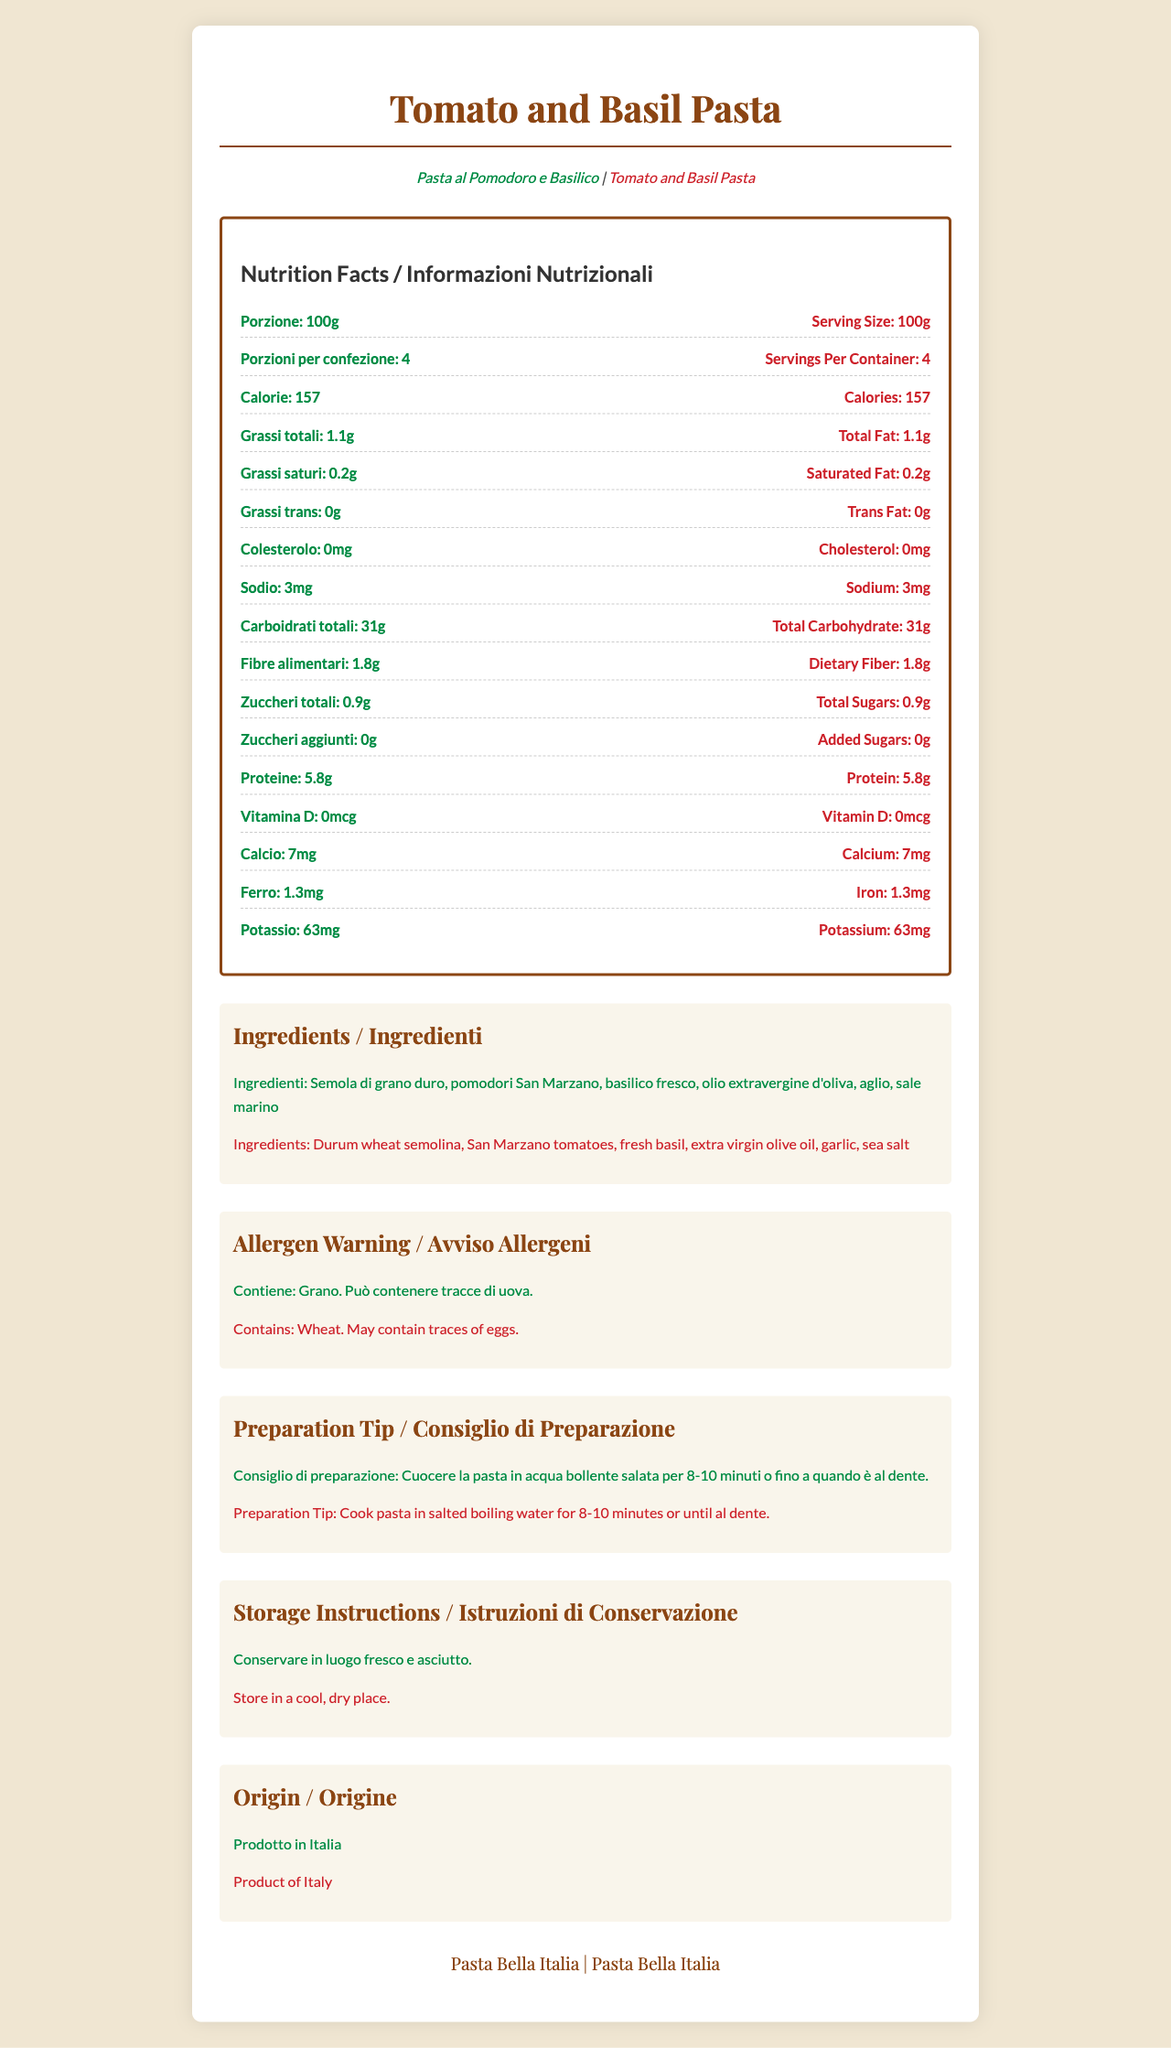What is the serving size in Italian? The serving size in Italian is stated as "Porzione: 100g".
Answer: Porzione: 100g How many servings per container are there? The document states "Servings Per Container: 4".
Answer: 4 How much sodium does a serving contain in English? The English section of the nutrition facts lists sodium as "3mg".
Answer: 3mg What is the amount of dietary fiber in this pasta? The nutritional information shows "Dietary Fiber: 1.8g" in the English section and "Fibre alimentari: 1.8g" in the Italian section.
Answer: 1.8g Which vitamin content is mentioned in the document? The document lists "Vitamin D: 0mcg" in the nutrition facts.
Answer: Vitamin D What are the main ingredients of this pasta dish in Italian? The Italian section lists the ingredients as "Semola di grano duro, pomodori San Marzano, basilico fresco, olio extravergine d'oliva, aglio, sale marino".
Answer: Semola di grano duro, pomodori San Marzano, basilico fresco, olio extravergine d'oliva, aglio, sale marino How much cholesterol does one serving contain? The nutritional information states "Cholesterol: 0mg".
Answer: 0mg What is the name of the product in English? The product name in English is "Tomato and Basil Pasta".
Answer: Tomato and Basil Pasta What is the preparation tip for this pasta? The preparation tip in English is "Cook pasta in salted boiling water for 8-10 minutes or until al dente."
Answer: Cook pasta in salted boiling water for 8-10 minutes or until al dente. What is the brand name of the pasta? The brand name is “Pasta Bella Italia”.
Answer: Pasta Bella Italia Which of the following ingredients is NOT listed in the document? A. Basilico fresco B. Aglio C. Origano D. Olio extravergine d'oliva The ingredients in the document are semola di grano duro (durum wheat semolina), pomodori San Marzano, basilico fresco (fresh basil), olio extravergine d'oliva (extra virgin olive oil), aglio (garlic), and sale marino (sea salt). Origano (oregano) is not listed.
Answer: C. Origano Which of the following nutrients has the highest amount in one serving? 1. Protein 2. Total Carbohydrate 3. Total Sugars 4. Total Fat The nutritional facts state that Total Carbohydrate is 31g, which is higher than Protein (5.8g), Total Sugars (0.9g), and Total Fat (1.1g).
Answer: 2. Total Carbohydrate Does the pasta contain any added sugars? The nutritional information states "Added Sugars: 0g".
Answer: No Summarize the document in a few sentences. The document is a bilingual (Italian and English) nutrition facts label for Tomato and Basil Pasta. It includes information about the serving size, nutrient content, ingredients, preparation tips, and storage instructions, with an emphasis on bilingual presentation. The product is identified as originating from Italy, and it is produced by the brand Pasta Bella Italia.
Answer: This document provides the nutrition facts and ingredient list for "Tomato and Basil Pasta" (Pasta al Pomodoro e Basilico), produced by Pasta Bella Italia. It includes bilingual information in Italian and English, detailing serving size, servings per container, calories, various nutrient contents, allergen warnings, preparation tips, and storage instructions. The pasta is a product of Italy. What is the main difference between the dietary fiber and total sugars content? The dietary fiber content is listed as 1.8g, whereas the total sugars content is 0.9g.
Answer: Dietary Fiber is 1.8g while Total Sugars is 0.9g Is the exact amount of potassium in milligrams per serving provided? The document lists "Potassium: 63mg" in the nutritional information.
Answer: Yes Can you determine the specific percentage of daily intake for each nutrient from this document? The document does not provide percentages of daily intake for the listed nutrients.
Answer: Cannot be determined 